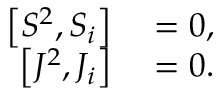<formula> <loc_0><loc_0><loc_500><loc_500>\begin{array} { r l } { \left [ S ^ { 2 } , S _ { i } \right ] } & = 0 , } \\ { \left [ J ^ { 2 } , J _ { i } \right ] } & = 0 . } \end{array}</formula> 